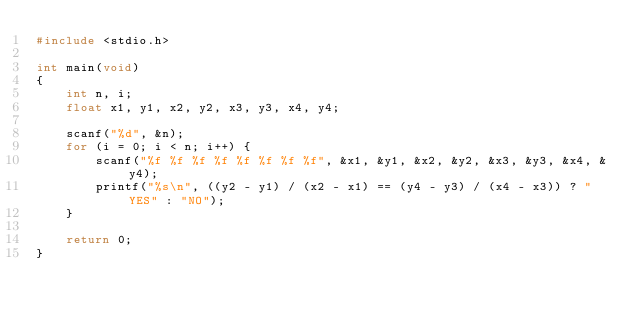<code> <loc_0><loc_0><loc_500><loc_500><_C_>#include <stdio.h>

int main(void)
{
    int n, i;
    float x1, y1, x2, y2, x3, y3, x4, y4;

    scanf("%d", &n);
    for (i = 0; i < n; i++) {
        scanf("%f %f %f %f %f %f %f %f", &x1, &y1, &x2, &y2, &x3, &y3, &x4, &y4);
        printf("%s\n", ((y2 - y1) / (x2 - x1) == (y4 - y3) / (x4 - x3)) ? "YES" : "NO");
    }

    return 0;
}</code> 